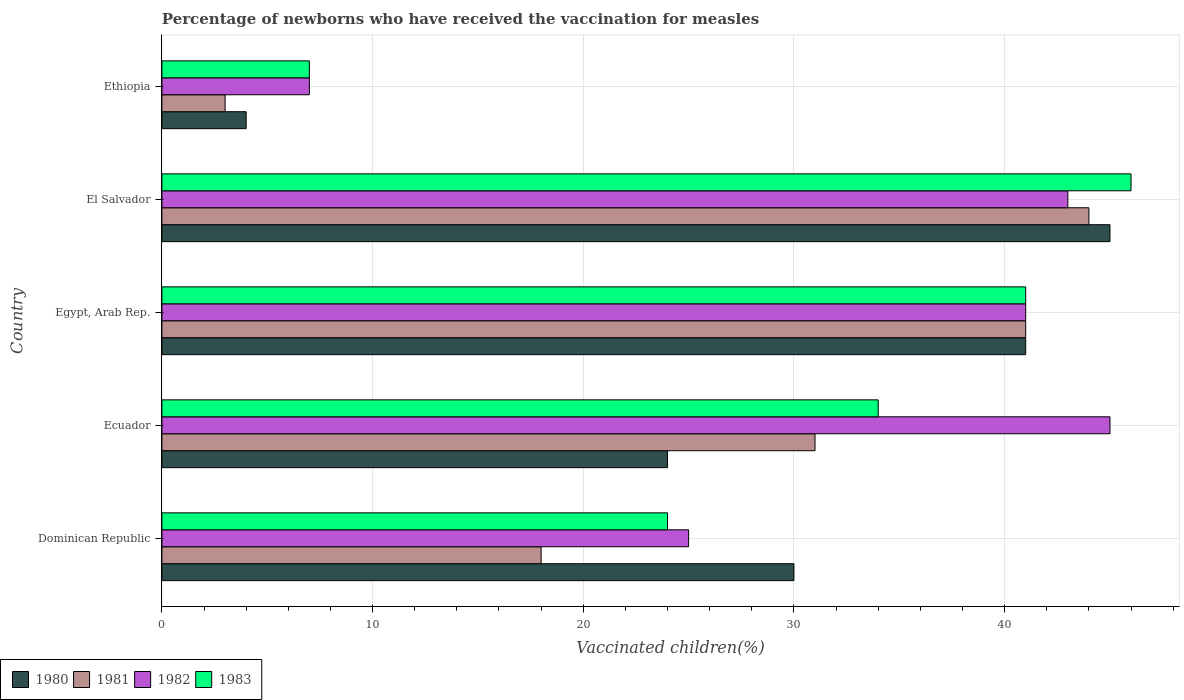Are the number of bars on each tick of the Y-axis equal?
Your answer should be compact. Yes. How many bars are there on the 3rd tick from the bottom?
Provide a succinct answer. 4. What is the label of the 1st group of bars from the top?
Your response must be concise. Ethiopia. In how many cases, is the number of bars for a given country not equal to the number of legend labels?
Your answer should be very brief. 0. Across all countries, what is the minimum percentage of vaccinated children in 1983?
Your answer should be very brief. 7. In which country was the percentage of vaccinated children in 1981 maximum?
Your answer should be compact. El Salvador. In which country was the percentage of vaccinated children in 1981 minimum?
Your answer should be very brief. Ethiopia. What is the total percentage of vaccinated children in 1981 in the graph?
Offer a terse response. 137. What is the average percentage of vaccinated children in 1982 per country?
Offer a very short reply. 32.2. What is the difference between the percentage of vaccinated children in 1980 and percentage of vaccinated children in 1981 in El Salvador?
Ensure brevity in your answer.  1. What is the ratio of the percentage of vaccinated children in 1980 in Egypt, Arab Rep. to that in Ethiopia?
Ensure brevity in your answer.  10.25. Is the percentage of vaccinated children in 1980 in Ecuador less than that in Ethiopia?
Keep it short and to the point. No. What is the difference between the highest and the second highest percentage of vaccinated children in 1980?
Provide a short and direct response. 4. What is the difference between the highest and the lowest percentage of vaccinated children in 1980?
Offer a very short reply. 41. Is it the case that in every country, the sum of the percentage of vaccinated children in 1982 and percentage of vaccinated children in 1983 is greater than the percentage of vaccinated children in 1980?
Offer a terse response. Yes. How many bars are there?
Offer a very short reply. 20. Are all the bars in the graph horizontal?
Ensure brevity in your answer.  Yes. How many countries are there in the graph?
Provide a succinct answer. 5. What is the difference between two consecutive major ticks on the X-axis?
Your answer should be compact. 10. Are the values on the major ticks of X-axis written in scientific E-notation?
Offer a terse response. No. Does the graph contain any zero values?
Give a very brief answer. No. How many legend labels are there?
Give a very brief answer. 4. How are the legend labels stacked?
Make the answer very short. Horizontal. What is the title of the graph?
Give a very brief answer. Percentage of newborns who have received the vaccination for measles. What is the label or title of the X-axis?
Provide a succinct answer. Vaccinated children(%). What is the Vaccinated children(%) of 1980 in Dominican Republic?
Offer a very short reply. 30. What is the Vaccinated children(%) in 1981 in Dominican Republic?
Give a very brief answer. 18. What is the Vaccinated children(%) of 1982 in Dominican Republic?
Offer a terse response. 25. What is the Vaccinated children(%) of 1980 in Ecuador?
Provide a succinct answer. 24. What is the Vaccinated children(%) of 1981 in Ecuador?
Ensure brevity in your answer.  31. What is the Vaccinated children(%) of 1982 in Ecuador?
Provide a succinct answer. 45. What is the Vaccinated children(%) of 1980 in Egypt, Arab Rep.?
Give a very brief answer. 41. What is the Vaccinated children(%) of 1981 in Egypt, Arab Rep.?
Keep it short and to the point. 41. What is the Vaccinated children(%) of 1983 in Egypt, Arab Rep.?
Your response must be concise. 41. What is the Vaccinated children(%) of 1980 in El Salvador?
Offer a very short reply. 45. What is the Vaccinated children(%) of 1982 in El Salvador?
Keep it short and to the point. 43. What is the Vaccinated children(%) in 1981 in Ethiopia?
Offer a terse response. 3. What is the Vaccinated children(%) of 1983 in Ethiopia?
Offer a very short reply. 7. Across all countries, what is the minimum Vaccinated children(%) of 1980?
Offer a very short reply. 4. Across all countries, what is the minimum Vaccinated children(%) of 1983?
Your answer should be very brief. 7. What is the total Vaccinated children(%) in 1980 in the graph?
Give a very brief answer. 144. What is the total Vaccinated children(%) in 1981 in the graph?
Provide a succinct answer. 137. What is the total Vaccinated children(%) of 1982 in the graph?
Provide a succinct answer. 161. What is the total Vaccinated children(%) in 1983 in the graph?
Give a very brief answer. 152. What is the difference between the Vaccinated children(%) in 1980 in Dominican Republic and that in Ecuador?
Your answer should be very brief. 6. What is the difference between the Vaccinated children(%) of 1981 in Dominican Republic and that in Ecuador?
Ensure brevity in your answer.  -13. What is the difference between the Vaccinated children(%) of 1983 in Dominican Republic and that in Ecuador?
Provide a succinct answer. -10. What is the difference between the Vaccinated children(%) of 1982 in Dominican Republic and that in Egypt, Arab Rep.?
Keep it short and to the point. -16. What is the difference between the Vaccinated children(%) of 1983 in Dominican Republic and that in Egypt, Arab Rep.?
Offer a terse response. -17. What is the difference between the Vaccinated children(%) in 1981 in Dominican Republic and that in El Salvador?
Provide a succinct answer. -26. What is the difference between the Vaccinated children(%) in 1983 in Dominican Republic and that in El Salvador?
Give a very brief answer. -22. What is the difference between the Vaccinated children(%) in 1982 in Dominican Republic and that in Ethiopia?
Your answer should be compact. 18. What is the difference between the Vaccinated children(%) of 1981 in Ecuador and that in Egypt, Arab Rep.?
Your response must be concise. -10. What is the difference between the Vaccinated children(%) of 1982 in Ecuador and that in Egypt, Arab Rep.?
Your answer should be very brief. 4. What is the difference between the Vaccinated children(%) in 1983 in Ecuador and that in Egypt, Arab Rep.?
Keep it short and to the point. -7. What is the difference between the Vaccinated children(%) of 1980 in Ecuador and that in El Salvador?
Offer a very short reply. -21. What is the difference between the Vaccinated children(%) of 1981 in Ecuador and that in El Salvador?
Your answer should be compact. -13. What is the difference between the Vaccinated children(%) in 1982 in Ecuador and that in El Salvador?
Make the answer very short. 2. What is the difference between the Vaccinated children(%) of 1983 in Ecuador and that in El Salvador?
Make the answer very short. -12. What is the difference between the Vaccinated children(%) in 1981 in Ecuador and that in Ethiopia?
Your answer should be very brief. 28. What is the difference between the Vaccinated children(%) of 1983 in Egypt, Arab Rep. and that in Ethiopia?
Keep it short and to the point. 34. What is the difference between the Vaccinated children(%) of 1982 in Dominican Republic and the Vaccinated children(%) of 1983 in Ecuador?
Ensure brevity in your answer.  -9. What is the difference between the Vaccinated children(%) of 1980 in Dominican Republic and the Vaccinated children(%) of 1983 in El Salvador?
Keep it short and to the point. -16. What is the difference between the Vaccinated children(%) in 1981 in Dominican Republic and the Vaccinated children(%) in 1983 in El Salvador?
Ensure brevity in your answer.  -28. What is the difference between the Vaccinated children(%) in 1980 in Dominican Republic and the Vaccinated children(%) in 1982 in Ethiopia?
Give a very brief answer. 23. What is the difference between the Vaccinated children(%) in 1981 in Dominican Republic and the Vaccinated children(%) in 1982 in Ethiopia?
Make the answer very short. 11. What is the difference between the Vaccinated children(%) in 1982 in Dominican Republic and the Vaccinated children(%) in 1983 in Ethiopia?
Your answer should be very brief. 18. What is the difference between the Vaccinated children(%) of 1980 in Ecuador and the Vaccinated children(%) of 1981 in Egypt, Arab Rep.?
Offer a terse response. -17. What is the difference between the Vaccinated children(%) of 1981 in Ecuador and the Vaccinated children(%) of 1982 in Egypt, Arab Rep.?
Ensure brevity in your answer.  -10. What is the difference between the Vaccinated children(%) in 1982 in Ecuador and the Vaccinated children(%) in 1983 in Egypt, Arab Rep.?
Keep it short and to the point. 4. What is the difference between the Vaccinated children(%) in 1980 in Ecuador and the Vaccinated children(%) in 1982 in El Salvador?
Your answer should be very brief. -19. What is the difference between the Vaccinated children(%) of 1980 in Ecuador and the Vaccinated children(%) of 1983 in El Salvador?
Provide a succinct answer. -22. What is the difference between the Vaccinated children(%) in 1981 in Ecuador and the Vaccinated children(%) in 1983 in El Salvador?
Offer a terse response. -15. What is the difference between the Vaccinated children(%) of 1980 in Ecuador and the Vaccinated children(%) of 1981 in Ethiopia?
Offer a terse response. 21. What is the difference between the Vaccinated children(%) of 1980 in Ecuador and the Vaccinated children(%) of 1982 in Ethiopia?
Your response must be concise. 17. What is the difference between the Vaccinated children(%) of 1980 in Ecuador and the Vaccinated children(%) of 1983 in Ethiopia?
Make the answer very short. 17. What is the difference between the Vaccinated children(%) of 1981 in Ecuador and the Vaccinated children(%) of 1982 in Ethiopia?
Offer a very short reply. 24. What is the difference between the Vaccinated children(%) of 1981 in Ecuador and the Vaccinated children(%) of 1983 in Ethiopia?
Give a very brief answer. 24. What is the difference between the Vaccinated children(%) of 1980 in Egypt, Arab Rep. and the Vaccinated children(%) of 1981 in El Salvador?
Your answer should be compact. -3. What is the difference between the Vaccinated children(%) of 1980 in Egypt, Arab Rep. and the Vaccinated children(%) of 1982 in El Salvador?
Ensure brevity in your answer.  -2. What is the difference between the Vaccinated children(%) in 1980 in Egypt, Arab Rep. and the Vaccinated children(%) in 1983 in El Salvador?
Provide a short and direct response. -5. What is the difference between the Vaccinated children(%) in 1981 in Egypt, Arab Rep. and the Vaccinated children(%) in 1983 in El Salvador?
Your answer should be compact. -5. What is the difference between the Vaccinated children(%) of 1982 in Egypt, Arab Rep. and the Vaccinated children(%) of 1983 in El Salvador?
Offer a very short reply. -5. What is the difference between the Vaccinated children(%) in 1980 in Egypt, Arab Rep. and the Vaccinated children(%) in 1982 in Ethiopia?
Your response must be concise. 34. What is the difference between the Vaccinated children(%) of 1981 in Egypt, Arab Rep. and the Vaccinated children(%) of 1982 in Ethiopia?
Your answer should be very brief. 34. What is the difference between the Vaccinated children(%) of 1981 in Egypt, Arab Rep. and the Vaccinated children(%) of 1983 in Ethiopia?
Give a very brief answer. 34. What is the difference between the Vaccinated children(%) of 1982 in Egypt, Arab Rep. and the Vaccinated children(%) of 1983 in Ethiopia?
Your response must be concise. 34. What is the difference between the Vaccinated children(%) in 1981 in El Salvador and the Vaccinated children(%) in 1982 in Ethiopia?
Offer a very short reply. 37. What is the difference between the Vaccinated children(%) in 1982 in El Salvador and the Vaccinated children(%) in 1983 in Ethiopia?
Give a very brief answer. 36. What is the average Vaccinated children(%) of 1980 per country?
Your answer should be compact. 28.8. What is the average Vaccinated children(%) in 1981 per country?
Give a very brief answer. 27.4. What is the average Vaccinated children(%) in 1982 per country?
Your response must be concise. 32.2. What is the average Vaccinated children(%) in 1983 per country?
Keep it short and to the point. 30.4. What is the difference between the Vaccinated children(%) in 1980 and Vaccinated children(%) in 1983 in Dominican Republic?
Your answer should be very brief. 6. What is the difference between the Vaccinated children(%) in 1981 and Vaccinated children(%) in 1982 in Dominican Republic?
Make the answer very short. -7. What is the difference between the Vaccinated children(%) of 1981 and Vaccinated children(%) of 1983 in Dominican Republic?
Keep it short and to the point. -6. What is the difference between the Vaccinated children(%) in 1982 and Vaccinated children(%) in 1983 in Dominican Republic?
Provide a succinct answer. 1. What is the difference between the Vaccinated children(%) of 1980 and Vaccinated children(%) of 1981 in Ecuador?
Your answer should be very brief. -7. What is the difference between the Vaccinated children(%) of 1980 and Vaccinated children(%) of 1982 in Ecuador?
Give a very brief answer. -21. What is the difference between the Vaccinated children(%) of 1981 and Vaccinated children(%) of 1982 in Ecuador?
Ensure brevity in your answer.  -14. What is the difference between the Vaccinated children(%) in 1981 and Vaccinated children(%) in 1983 in Ecuador?
Offer a terse response. -3. What is the difference between the Vaccinated children(%) in 1980 and Vaccinated children(%) in 1981 in Egypt, Arab Rep.?
Your answer should be compact. 0. What is the difference between the Vaccinated children(%) in 1980 and Vaccinated children(%) in 1982 in Egypt, Arab Rep.?
Provide a short and direct response. 0. What is the difference between the Vaccinated children(%) of 1981 and Vaccinated children(%) of 1983 in Egypt, Arab Rep.?
Offer a terse response. 0. What is the difference between the Vaccinated children(%) in 1980 and Vaccinated children(%) in 1981 in El Salvador?
Your response must be concise. 1. What is the difference between the Vaccinated children(%) in 1980 and Vaccinated children(%) in 1982 in El Salvador?
Offer a terse response. 2. What is the difference between the Vaccinated children(%) in 1981 and Vaccinated children(%) in 1982 in El Salvador?
Make the answer very short. 1. What is the difference between the Vaccinated children(%) of 1980 and Vaccinated children(%) of 1982 in Ethiopia?
Your answer should be compact. -3. What is the difference between the Vaccinated children(%) of 1982 and Vaccinated children(%) of 1983 in Ethiopia?
Offer a terse response. 0. What is the ratio of the Vaccinated children(%) in 1980 in Dominican Republic to that in Ecuador?
Ensure brevity in your answer.  1.25. What is the ratio of the Vaccinated children(%) in 1981 in Dominican Republic to that in Ecuador?
Make the answer very short. 0.58. What is the ratio of the Vaccinated children(%) in 1982 in Dominican Republic to that in Ecuador?
Provide a short and direct response. 0.56. What is the ratio of the Vaccinated children(%) in 1983 in Dominican Republic to that in Ecuador?
Your answer should be compact. 0.71. What is the ratio of the Vaccinated children(%) in 1980 in Dominican Republic to that in Egypt, Arab Rep.?
Your answer should be compact. 0.73. What is the ratio of the Vaccinated children(%) of 1981 in Dominican Republic to that in Egypt, Arab Rep.?
Provide a short and direct response. 0.44. What is the ratio of the Vaccinated children(%) in 1982 in Dominican Republic to that in Egypt, Arab Rep.?
Give a very brief answer. 0.61. What is the ratio of the Vaccinated children(%) of 1983 in Dominican Republic to that in Egypt, Arab Rep.?
Ensure brevity in your answer.  0.59. What is the ratio of the Vaccinated children(%) in 1980 in Dominican Republic to that in El Salvador?
Offer a very short reply. 0.67. What is the ratio of the Vaccinated children(%) of 1981 in Dominican Republic to that in El Salvador?
Keep it short and to the point. 0.41. What is the ratio of the Vaccinated children(%) of 1982 in Dominican Republic to that in El Salvador?
Make the answer very short. 0.58. What is the ratio of the Vaccinated children(%) in 1983 in Dominican Republic to that in El Salvador?
Ensure brevity in your answer.  0.52. What is the ratio of the Vaccinated children(%) in 1980 in Dominican Republic to that in Ethiopia?
Ensure brevity in your answer.  7.5. What is the ratio of the Vaccinated children(%) of 1982 in Dominican Republic to that in Ethiopia?
Offer a very short reply. 3.57. What is the ratio of the Vaccinated children(%) of 1983 in Dominican Republic to that in Ethiopia?
Your response must be concise. 3.43. What is the ratio of the Vaccinated children(%) in 1980 in Ecuador to that in Egypt, Arab Rep.?
Provide a short and direct response. 0.59. What is the ratio of the Vaccinated children(%) of 1981 in Ecuador to that in Egypt, Arab Rep.?
Offer a very short reply. 0.76. What is the ratio of the Vaccinated children(%) of 1982 in Ecuador to that in Egypt, Arab Rep.?
Your answer should be very brief. 1.1. What is the ratio of the Vaccinated children(%) in 1983 in Ecuador to that in Egypt, Arab Rep.?
Offer a very short reply. 0.83. What is the ratio of the Vaccinated children(%) of 1980 in Ecuador to that in El Salvador?
Give a very brief answer. 0.53. What is the ratio of the Vaccinated children(%) in 1981 in Ecuador to that in El Salvador?
Your response must be concise. 0.7. What is the ratio of the Vaccinated children(%) of 1982 in Ecuador to that in El Salvador?
Ensure brevity in your answer.  1.05. What is the ratio of the Vaccinated children(%) of 1983 in Ecuador to that in El Salvador?
Give a very brief answer. 0.74. What is the ratio of the Vaccinated children(%) in 1981 in Ecuador to that in Ethiopia?
Your response must be concise. 10.33. What is the ratio of the Vaccinated children(%) in 1982 in Ecuador to that in Ethiopia?
Keep it short and to the point. 6.43. What is the ratio of the Vaccinated children(%) of 1983 in Ecuador to that in Ethiopia?
Make the answer very short. 4.86. What is the ratio of the Vaccinated children(%) of 1980 in Egypt, Arab Rep. to that in El Salvador?
Give a very brief answer. 0.91. What is the ratio of the Vaccinated children(%) in 1981 in Egypt, Arab Rep. to that in El Salvador?
Offer a very short reply. 0.93. What is the ratio of the Vaccinated children(%) of 1982 in Egypt, Arab Rep. to that in El Salvador?
Your answer should be compact. 0.95. What is the ratio of the Vaccinated children(%) of 1983 in Egypt, Arab Rep. to that in El Salvador?
Make the answer very short. 0.89. What is the ratio of the Vaccinated children(%) in 1980 in Egypt, Arab Rep. to that in Ethiopia?
Give a very brief answer. 10.25. What is the ratio of the Vaccinated children(%) in 1981 in Egypt, Arab Rep. to that in Ethiopia?
Make the answer very short. 13.67. What is the ratio of the Vaccinated children(%) in 1982 in Egypt, Arab Rep. to that in Ethiopia?
Offer a terse response. 5.86. What is the ratio of the Vaccinated children(%) in 1983 in Egypt, Arab Rep. to that in Ethiopia?
Offer a terse response. 5.86. What is the ratio of the Vaccinated children(%) in 1980 in El Salvador to that in Ethiopia?
Your answer should be compact. 11.25. What is the ratio of the Vaccinated children(%) in 1981 in El Salvador to that in Ethiopia?
Your answer should be compact. 14.67. What is the ratio of the Vaccinated children(%) of 1982 in El Salvador to that in Ethiopia?
Give a very brief answer. 6.14. What is the ratio of the Vaccinated children(%) in 1983 in El Salvador to that in Ethiopia?
Offer a terse response. 6.57. What is the difference between the highest and the second highest Vaccinated children(%) of 1982?
Your response must be concise. 2. What is the difference between the highest and the second highest Vaccinated children(%) in 1983?
Give a very brief answer. 5. What is the difference between the highest and the lowest Vaccinated children(%) of 1982?
Make the answer very short. 38. 